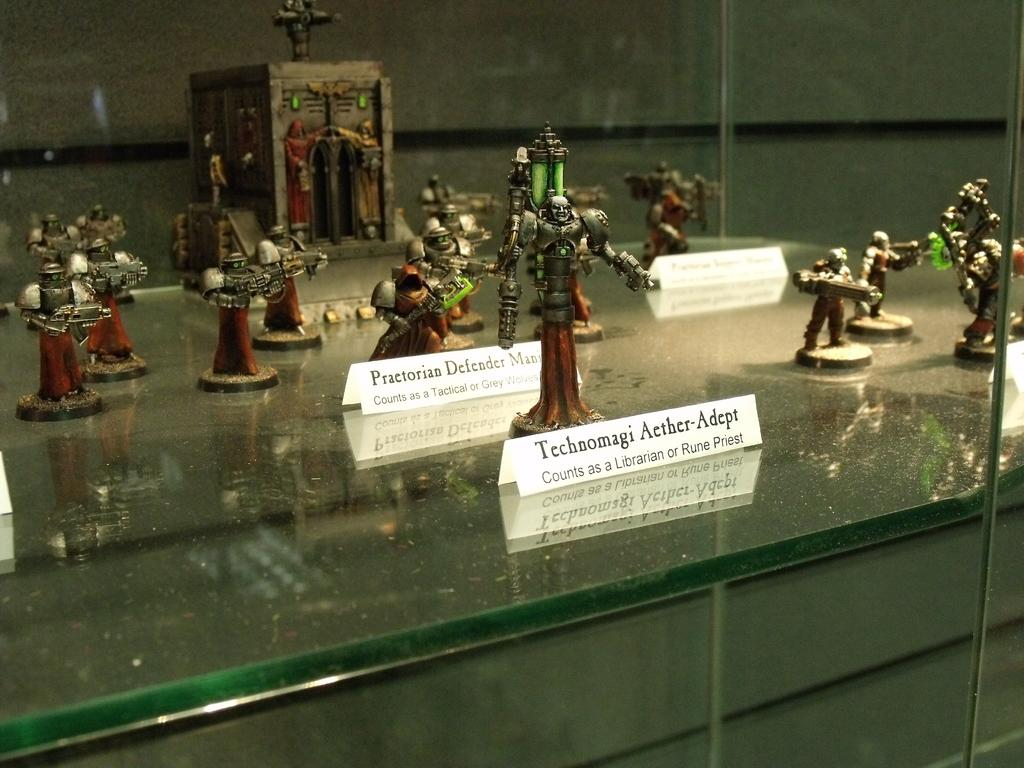What object is present in the image that is typically used for drinking? There is a glass in the image. What can be seen inside the glass? Small sculptures and name plates are visible through the glass. What type of table is the glass placed on in the image? There is a glass table in the image. What type of toys are visible on the table in the image? There are no toys visible on the table in the image. What type of beef is being served on the glass table in the image? There is no beef present in the image. 